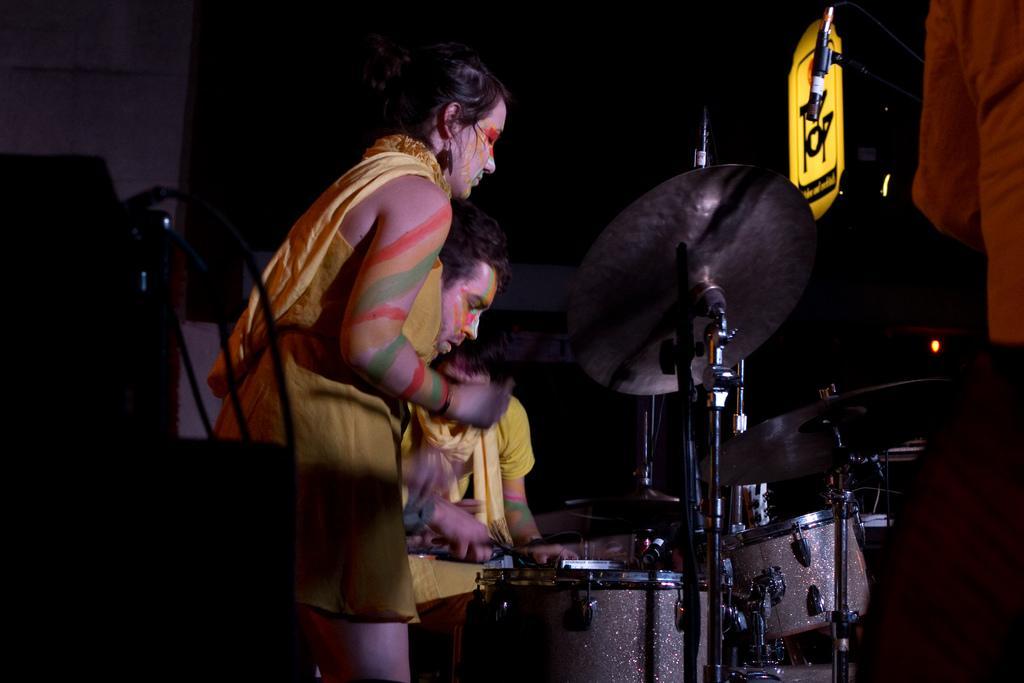In one or two sentences, can you explain what this image depicts? In the image there is a lady standing. On her face and hands there are painting. Beside her, there are few people. In front of them there are musical instruments. On the right corner of the image there is a person. And also there is a stand with mic. There is a poster with light. On the left side of the image there is an object with wires. And there is a blur background. 